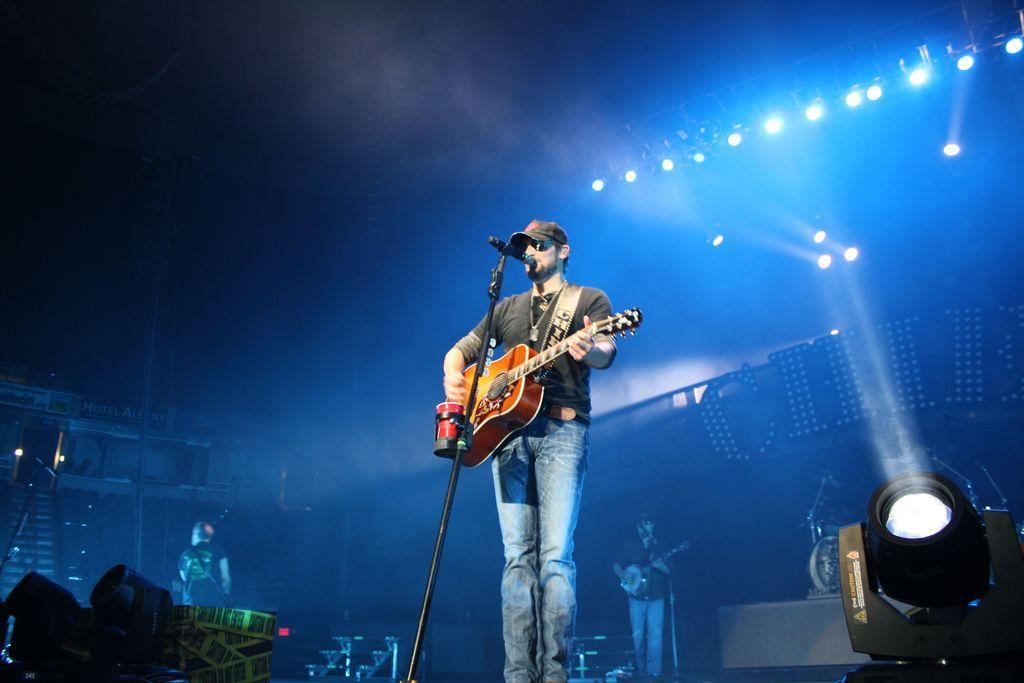How would you summarize this image in a sentence or two? As we can see in the image there is a man holding guitar and there is a mic over here. 